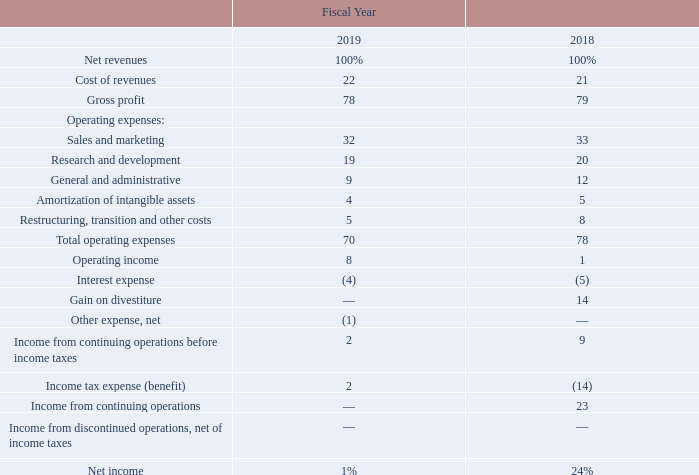Fiscal 2019 compared to fiscal 2018
The following table sets forth our Consolidated Statements of Operations data as a percentage of net revenues for the periods indicated:
Note: The percentages may not add due to rounding.
What does the table show? Consolidated statements of operations data as a percentage of net revenues for the periods indicated. What are the fiscal year periods indicated in the table? Fiscal 2019, fiscal 2018. What is the cost of revenue percentage for fiscal year 2019?
Answer scale should be: percent. 22. What is the change in cost of revenues relative to Net revenue from fiscal year 2018 to fiscal year 2019?
Answer scale should be: percent. 22-21
Answer: 1. What is the Sales and marketing costs expressed as a percentage of Total operating expenses in 2019?
Answer scale should be: percent. 32/70
Answer: 45.71. What is the change in Total operating expenses from fiscal year 2018 to fiscal year 2019?
Answer scale should be: percent. 70-78
Answer: -8. 